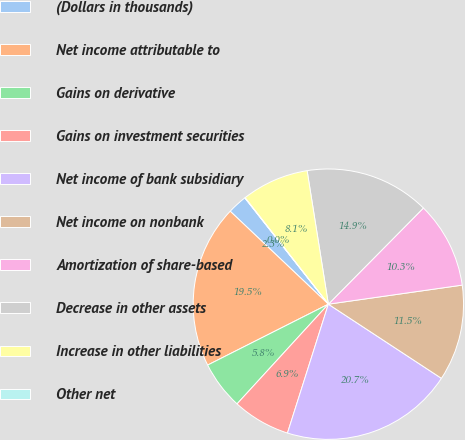Convert chart. <chart><loc_0><loc_0><loc_500><loc_500><pie_chart><fcel>(Dollars in thousands)<fcel>Net income attributable to<fcel>Gains on derivative<fcel>Gains on investment securities<fcel>Net income of bank subsidiary<fcel>Net income on nonbank<fcel>Amortization of share-based<fcel>Decrease in other assets<fcel>Increase in other liabilities<fcel>Other net<nl><fcel>2.33%<fcel>19.5%<fcel>5.76%<fcel>6.91%<fcel>20.65%<fcel>11.49%<fcel>10.34%<fcel>14.92%<fcel>8.05%<fcel>0.04%<nl></chart> 